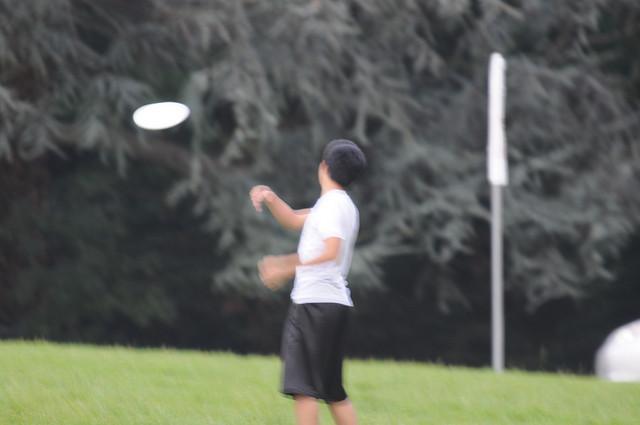How many people are visible?
Give a very brief answer. 1. 